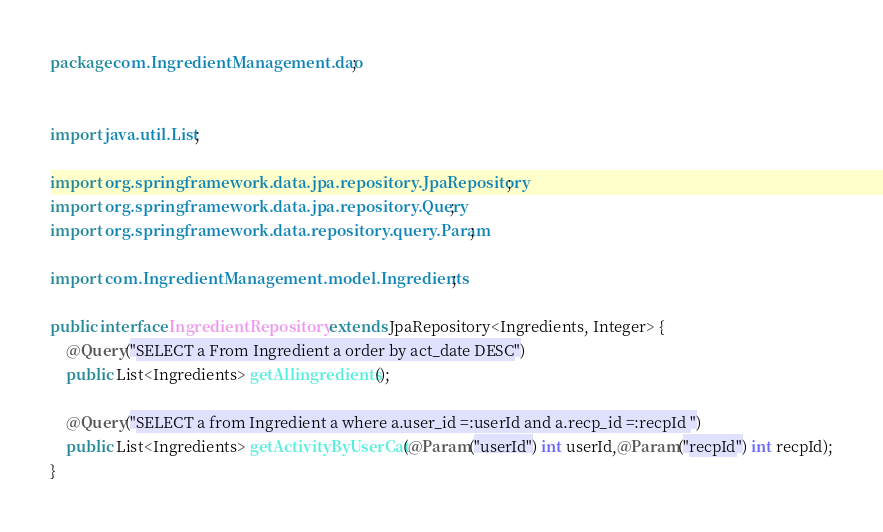Convert code to text. <code><loc_0><loc_0><loc_500><loc_500><_Java_>package com.IngredientManagement.dao;


import java.util.List;

import org.springframework.data.jpa.repository.JpaRepository;
import org.springframework.data.jpa.repository.Query;
import org.springframework.data.repository.query.Param;

import com.IngredientManagement.model.Ingredients;

public interface IngredientRepository extends JpaRepository<Ingredients, Integer> {
	@Query("SELECT a From Ingredient a order by act_date DESC")
	public List<Ingredients> getAllingredients();
	
	@Query("SELECT a from Ingredient a where a.user_id =:userId and a.recp_id =:recpId ")
	public List<Ingredients> getActivityByUserCat(@Param("userId") int userId,@Param("recpId") int recpId);
}
</code> 